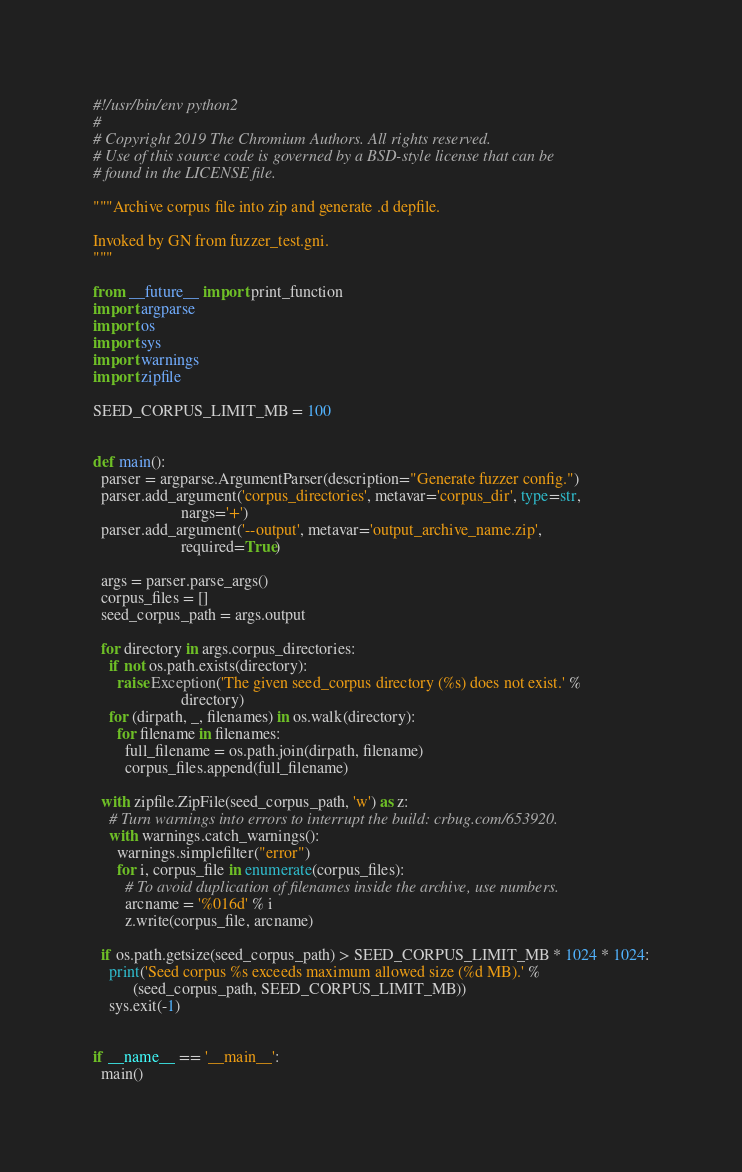Convert code to text. <code><loc_0><loc_0><loc_500><loc_500><_Python_>#!/usr/bin/env python2
#
# Copyright 2019 The Chromium Authors. All rights reserved.
# Use of this source code is governed by a BSD-style license that can be
# found in the LICENSE file.

"""Archive corpus file into zip and generate .d depfile.

Invoked by GN from fuzzer_test.gni.
"""

from __future__ import print_function
import argparse
import os
import sys
import warnings
import zipfile

SEED_CORPUS_LIMIT_MB = 100


def main():
  parser = argparse.ArgumentParser(description="Generate fuzzer config.")
  parser.add_argument('corpus_directories', metavar='corpus_dir', type=str,
                      nargs='+')
  parser.add_argument('--output', metavar='output_archive_name.zip',
                      required=True)

  args = parser.parse_args()
  corpus_files = []
  seed_corpus_path = args.output

  for directory in args.corpus_directories:
    if not os.path.exists(directory):
      raise Exception('The given seed_corpus directory (%s) does not exist.' %
                      directory)
    for (dirpath, _, filenames) in os.walk(directory):
      for filename in filenames:
        full_filename = os.path.join(dirpath, filename)
        corpus_files.append(full_filename)

  with zipfile.ZipFile(seed_corpus_path, 'w') as z:
    # Turn warnings into errors to interrupt the build: crbug.com/653920.
    with warnings.catch_warnings():
      warnings.simplefilter("error")
      for i, corpus_file in enumerate(corpus_files):
        # To avoid duplication of filenames inside the archive, use numbers.
        arcname = '%016d' % i
        z.write(corpus_file, arcname)

  if os.path.getsize(seed_corpus_path) > SEED_CORPUS_LIMIT_MB * 1024 * 1024:
    print('Seed corpus %s exceeds maximum allowed size (%d MB).' %
          (seed_corpus_path, SEED_CORPUS_LIMIT_MB))
    sys.exit(-1)


if __name__ == '__main__':
  main()
</code> 